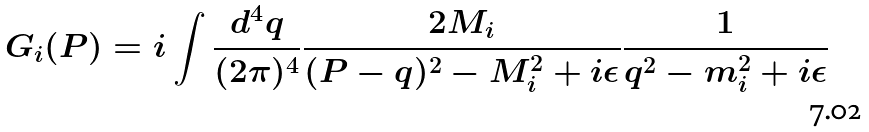<formula> <loc_0><loc_0><loc_500><loc_500>G _ { i } ( P ) = i \int \frac { d ^ { 4 } q } { ( 2 \pi ) ^ { 4 } } \frac { 2 M _ { i } } { ( P - q ) ^ { 2 } - M _ { i } ^ { 2 } + i \epsilon } \frac { 1 } { q ^ { 2 } - m _ { i } ^ { 2 } + i \epsilon }</formula> 